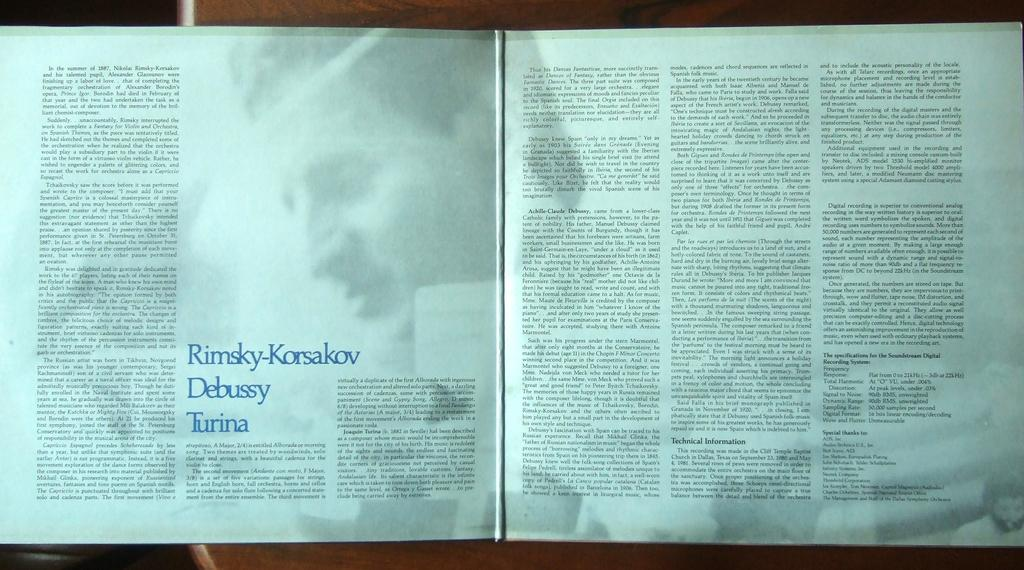What is on the table in the image? There is an open book on the table. What can be seen on the papers in the image? There is writing on the papers. Can you describe any human elements in the image? Yes, there are pictures of people in the image. How many cherries are on the table in the image? There are no cherries present in the image. What type of seed can be seen growing in the image? There is no seed growing in the image. 